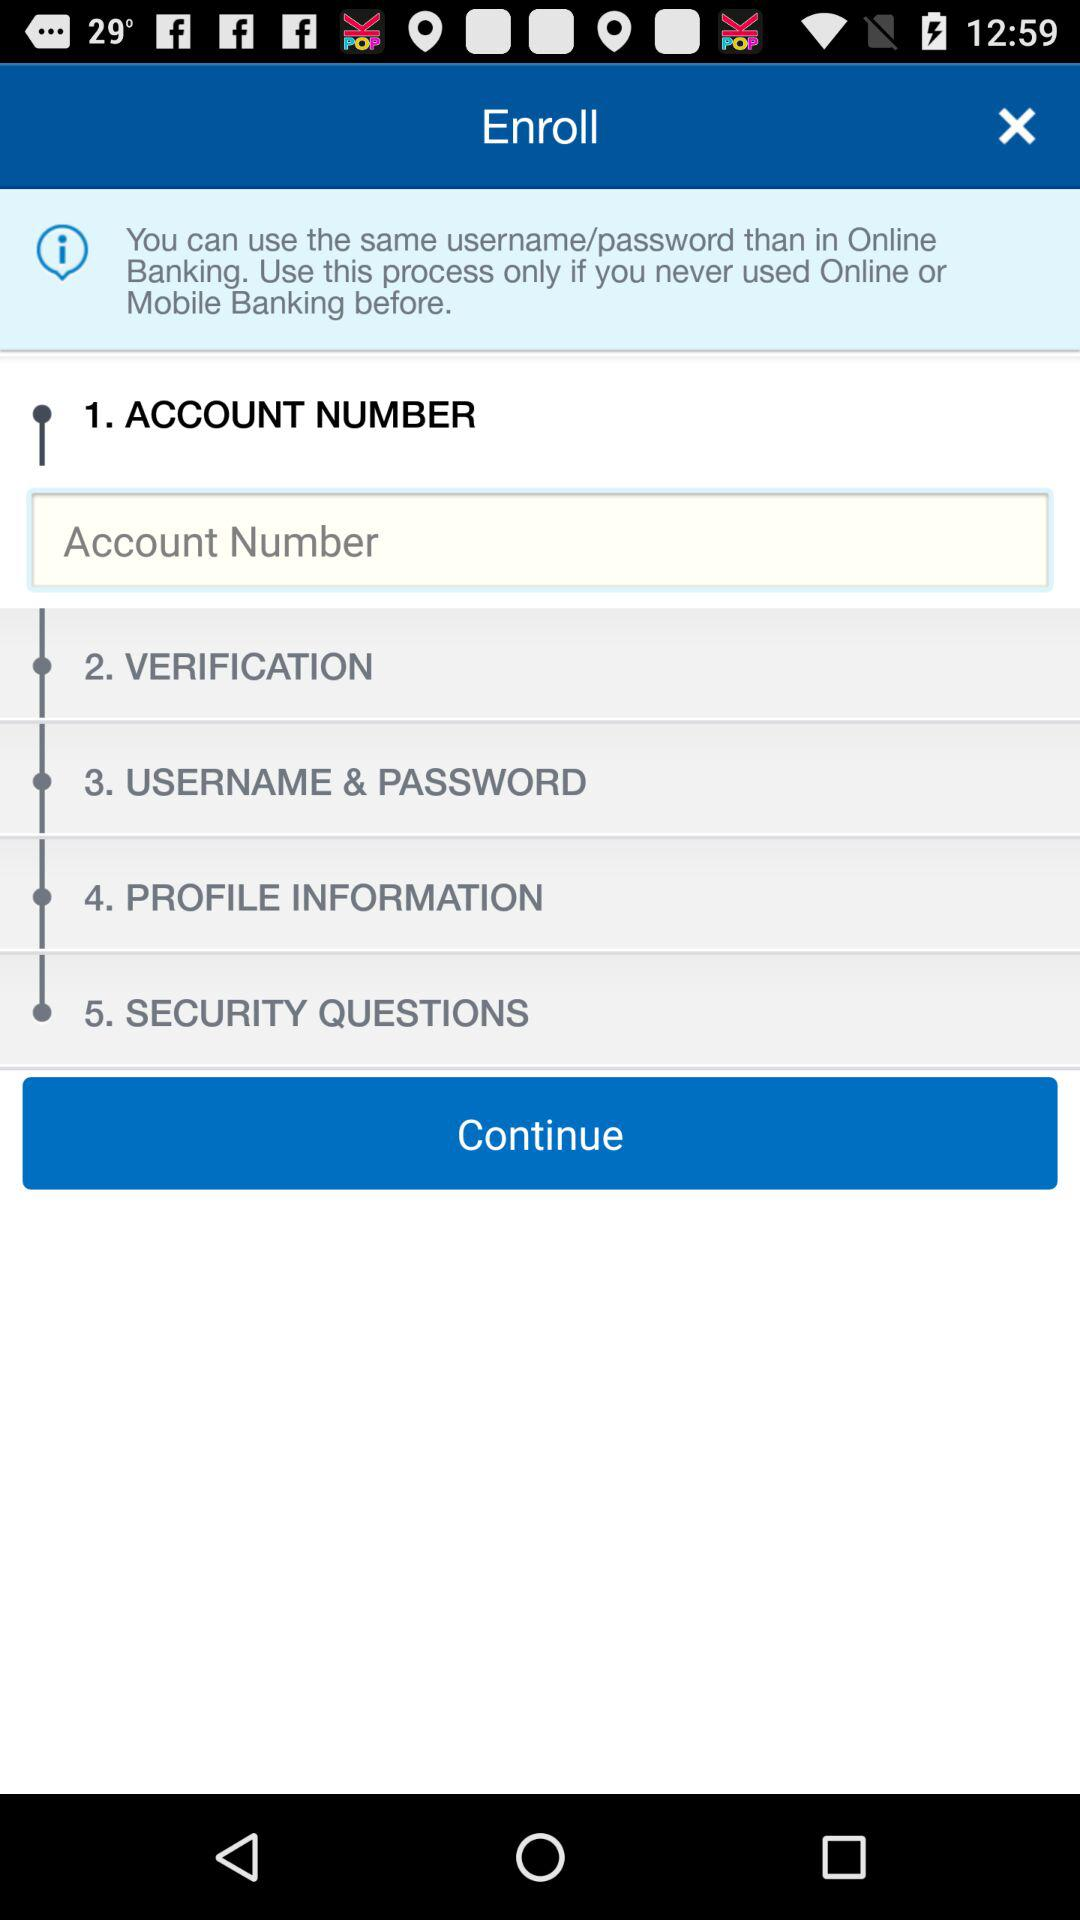How many steps are there in the enrollment process?
Answer the question using a single word or phrase. 5 